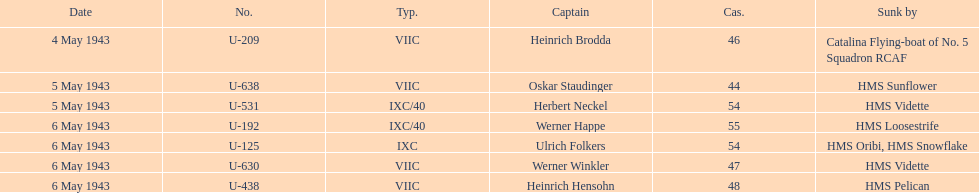Which date had at least 55 casualties? 6 May 1943. 